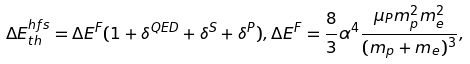Convert formula to latex. <formula><loc_0><loc_0><loc_500><loc_500>\Delta E ^ { h f s } _ { t h } = \Delta E ^ { F } ( 1 + \delta ^ { Q E D } + \delta ^ { S } + \delta ^ { P } ) , \Delta E ^ { F } = \frac { 8 } { 3 } \alpha ^ { 4 } \frac { \mu _ { P } m _ { p } ^ { 2 } m _ { e } ^ { 2 } } { ( m _ { p } + m _ { e } ) ^ { 3 } } ,</formula> 